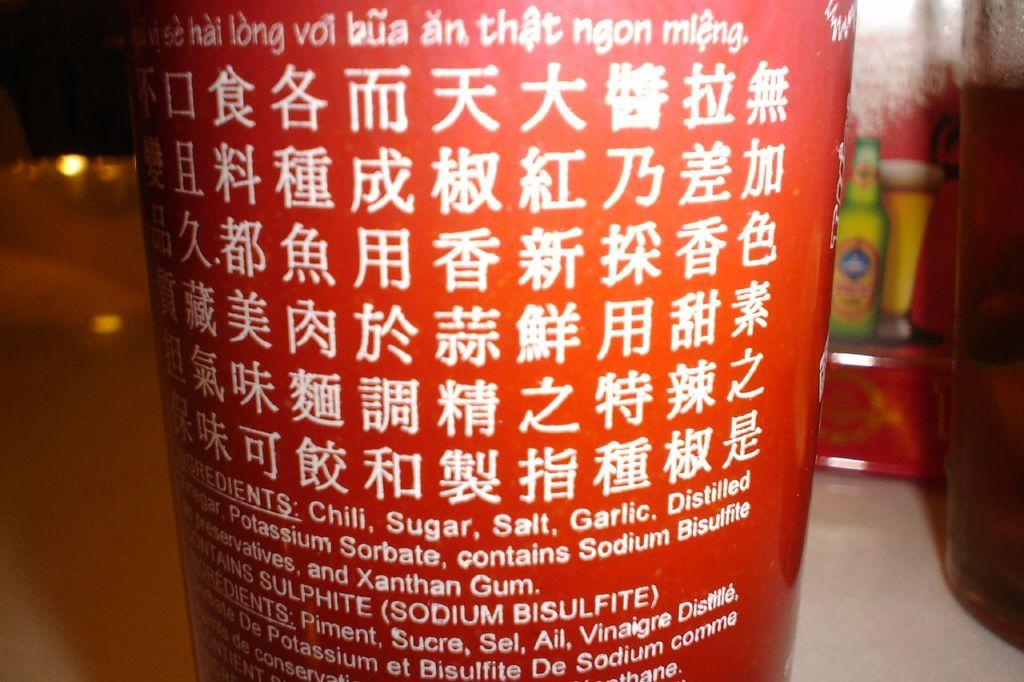<image>
Share a concise interpretation of the image provided. a red bottle of sauce with ingredients of chili, salt, etc 